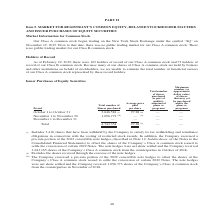From Square's financial document, What are the months provided in the period column? The document contains multiple relevant values: October, November, December. From the document: "October 1 to October 31 3,646,581 (i) 97.28 (ii) — — November 1 to November 30 1,096,773 (iii) — (ii) — — D ober 1 to October 31 3,646,581 (i) 97.28 (..." Also, What is the Total number of Shares purchased across the periods? According to the financial document, 4,743,354. The relevant text states: "Total 4,743,354 97.28 (ii) — —..." Also, How many shares did the company receive from Company’s Class A common stock from the counterparties in November of 2018? According to the financial document, 1,096,773. The relevant text states: ",581 (i) 97.28 (ii) — — November 1 to November 30 1,096,773 (iii) — (ii) — — December 1 to December 31 — — — —..." Also, can you calculate: What is the percentage amount of the number of shares purchased in October? Based on the calculation: 3,646,581 / 4,743,354 , the result is 76.88 (percentage). This is based on the information: "Total 4,743,354 97.28 (ii) — — October 1 to October 31 3,646,581 (i) 97.28 (ii) — — November 1 to November 30 1,096,773 (iii) — (ii) — — December 1 to December 31 —..." The key data points involved are: 3,646,581, 4,743,354. Also, can you calculate: What is the average total number of shares purchased? To answer this question, I need to perform calculations using the financial data. The calculation is: (3,646,581 + 1,096,773) / 3 , which equals 1581118. This is based on the information: ",581 (i) 97.28 (ii) — — November 1 to November 30 1,096,773 (iii) — (ii) — — December 1 to December 31 — — — — October 1 to October 31 3,646,581 (i) 97.28 (ii) — — November 1 to November 30 1,096,773 ..." The key data points involved are: 1,096,773, 3,646,581. Additionally, Which period has the largest number of shares purchased?   October 1 to October 31. The document states: "October 1 to October 31 3,646,581 (i) 97.28 (ii) — — November 1 to November 30 1,096,773 (iii) — (ii) — — December 1 to Dec..." 